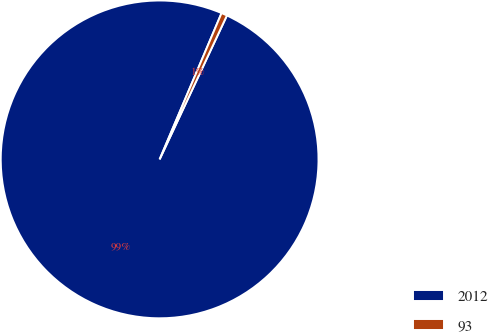<chart> <loc_0><loc_0><loc_500><loc_500><pie_chart><fcel>2012<fcel>93<nl><fcel>99.41%<fcel>0.59%<nl></chart> 